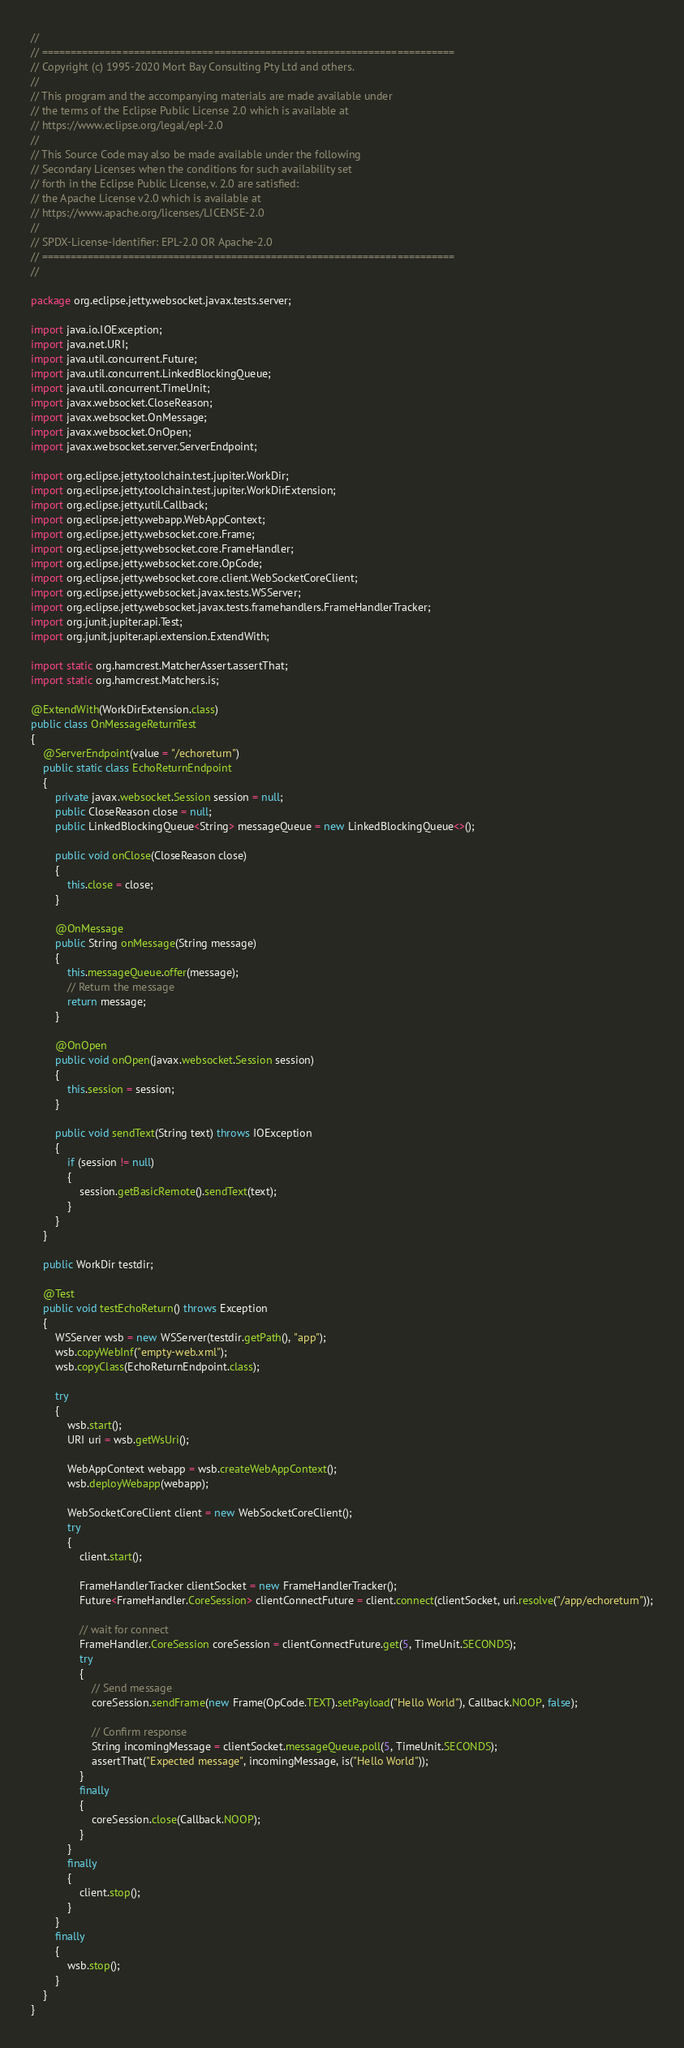Convert code to text. <code><loc_0><loc_0><loc_500><loc_500><_Java_>//
// ========================================================================
// Copyright (c) 1995-2020 Mort Bay Consulting Pty Ltd and others.
//
// This program and the accompanying materials are made available under
// the terms of the Eclipse Public License 2.0 which is available at
// https://www.eclipse.org/legal/epl-2.0
//
// This Source Code may also be made available under the following
// Secondary Licenses when the conditions for such availability set
// forth in the Eclipse Public License, v. 2.0 are satisfied:
// the Apache License v2.0 which is available at
// https://www.apache.org/licenses/LICENSE-2.0
//
// SPDX-License-Identifier: EPL-2.0 OR Apache-2.0
// ========================================================================
//

package org.eclipse.jetty.websocket.javax.tests.server;

import java.io.IOException;
import java.net.URI;
import java.util.concurrent.Future;
import java.util.concurrent.LinkedBlockingQueue;
import java.util.concurrent.TimeUnit;
import javax.websocket.CloseReason;
import javax.websocket.OnMessage;
import javax.websocket.OnOpen;
import javax.websocket.server.ServerEndpoint;

import org.eclipse.jetty.toolchain.test.jupiter.WorkDir;
import org.eclipse.jetty.toolchain.test.jupiter.WorkDirExtension;
import org.eclipse.jetty.util.Callback;
import org.eclipse.jetty.webapp.WebAppContext;
import org.eclipse.jetty.websocket.core.Frame;
import org.eclipse.jetty.websocket.core.FrameHandler;
import org.eclipse.jetty.websocket.core.OpCode;
import org.eclipse.jetty.websocket.core.client.WebSocketCoreClient;
import org.eclipse.jetty.websocket.javax.tests.WSServer;
import org.eclipse.jetty.websocket.javax.tests.framehandlers.FrameHandlerTracker;
import org.junit.jupiter.api.Test;
import org.junit.jupiter.api.extension.ExtendWith;

import static org.hamcrest.MatcherAssert.assertThat;
import static org.hamcrest.Matchers.is;

@ExtendWith(WorkDirExtension.class)
public class OnMessageReturnTest
{
    @ServerEndpoint(value = "/echoreturn")
    public static class EchoReturnEndpoint
    {
        private javax.websocket.Session session = null;
        public CloseReason close = null;
        public LinkedBlockingQueue<String> messageQueue = new LinkedBlockingQueue<>();

        public void onClose(CloseReason close)
        {
            this.close = close;
        }

        @OnMessage
        public String onMessage(String message)
        {
            this.messageQueue.offer(message);
            // Return the message
            return message;
        }

        @OnOpen
        public void onOpen(javax.websocket.Session session)
        {
            this.session = session;
        }

        public void sendText(String text) throws IOException
        {
            if (session != null)
            {
                session.getBasicRemote().sendText(text);
            }
        }
    }

    public WorkDir testdir;

    @Test
    public void testEchoReturn() throws Exception
    {
        WSServer wsb = new WSServer(testdir.getPath(), "app");
        wsb.copyWebInf("empty-web.xml");
        wsb.copyClass(EchoReturnEndpoint.class);

        try
        {
            wsb.start();
            URI uri = wsb.getWsUri();

            WebAppContext webapp = wsb.createWebAppContext();
            wsb.deployWebapp(webapp);

            WebSocketCoreClient client = new WebSocketCoreClient();
            try
            {
                client.start();

                FrameHandlerTracker clientSocket = new FrameHandlerTracker();
                Future<FrameHandler.CoreSession> clientConnectFuture = client.connect(clientSocket, uri.resolve("/app/echoreturn"));

                // wait for connect
                FrameHandler.CoreSession coreSession = clientConnectFuture.get(5, TimeUnit.SECONDS);
                try
                {
                    // Send message
                    coreSession.sendFrame(new Frame(OpCode.TEXT).setPayload("Hello World"), Callback.NOOP, false);

                    // Confirm response
                    String incomingMessage = clientSocket.messageQueue.poll(5, TimeUnit.SECONDS);
                    assertThat("Expected message", incomingMessage, is("Hello World"));
                }
                finally
                {
                    coreSession.close(Callback.NOOP);
                }
            }
            finally
            {
                client.stop();
            }
        }
        finally
        {
            wsb.stop();
        }
    }
}
</code> 